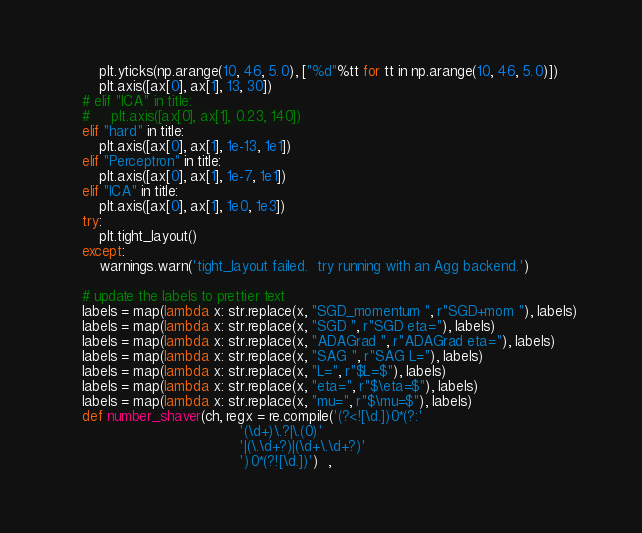Convert code to text. <code><loc_0><loc_0><loc_500><loc_500><_Python_>        plt.yticks(np.arange(10, 46, 5.0), ["%d"%tt for tt in np.arange(10, 46, 5.0)])
        plt.axis([ax[0], ax[1], 13, 30])
    # elif "ICA" in title:
    #     plt.axis([ax[0], ax[1], 0.23, 140])
    elif "hard" in title:
        plt.axis([ax[0], ax[1], 1e-13, 1e1])
    elif "Perceptron" in title:
        plt.axis([ax[0], ax[1], 1e-7, 1e1])
    elif "ICA" in title:
        plt.axis([ax[0], ax[1], 1e0, 1e3])
    try:
        plt.tight_layout()
    except:
        warnings.warn('tight_layout failed.  try running with an Agg backend.')

    # update the labels to prettier text
    labels = map(lambda x: str.replace(x, "SGD_momentum ", r"SGD+mom "), labels)
    labels = map(lambda x: str.replace(x, "SGD ", r"SGD eta="), labels)
    labels = map(lambda x: str.replace(x, "ADAGrad ", r"ADAGrad eta="), labels)
    labels = map(lambda x: str.replace(x, "SAG ", r"SAG L="), labels)
    labels = map(lambda x: str.replace(x, "L=", r"$L=$"), labels)
    labels = map(lambda x: str.replace(x, "eta=", r"$\eta=$"), labels)
    labels = map(lambda x: str.replace(x, "mu=", r"$\mu=$"), labels)
    def number_shaver(ch, regx = re.compile('(?<![\d.])0*(?:'
                                        '(\d+)\.?|\.(0)'
                                        '|(\.\d+?)|(\d+\.\d+?)'
                                        ')0*(?![\d.])')  ,</code> 